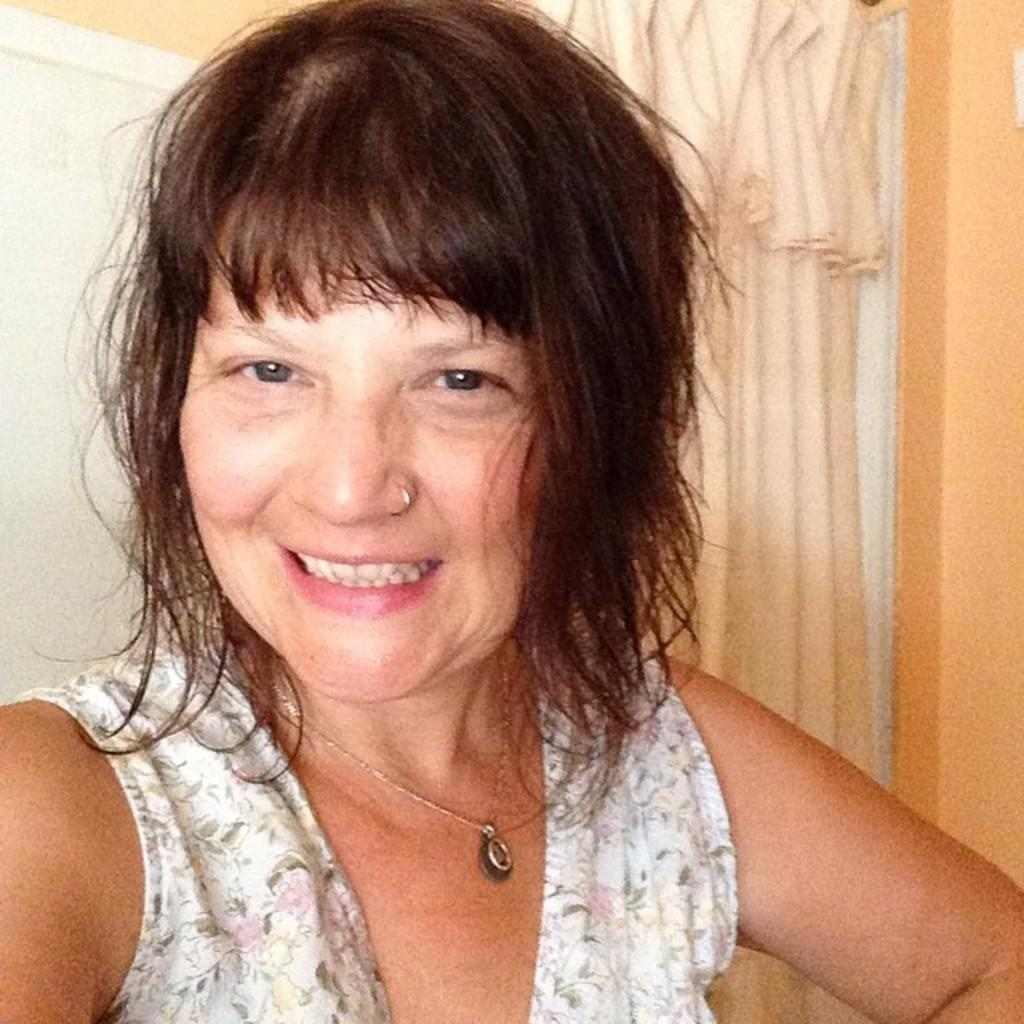Who is present in the image? There is a woman in the image. What is the woman's facial expression? The woman is smiling. What can be seen in the background of the image? There is a curtain visible in the image. What flavor of ice cream is the woman holding in the image? There is no ice cream present in the image. 